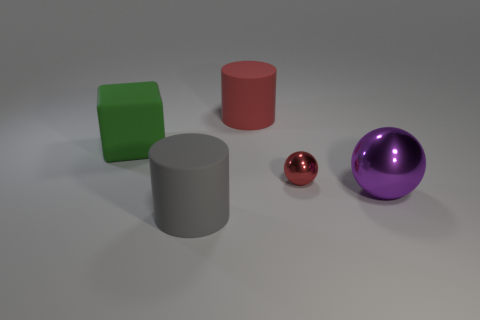Add 1 tiny purple rubber cubes. How many objects exist? 6 Subtract all balls. How many objects are left? 3 Add 3 metallic objects. How many metallic objects are left? 5 Add 5 big yellow balls. How many big yellow balls exist? 5 Subtract 0 blue balls. How many objects are left? 5 Subtract all tiny green things. Subtract all purple shiny spheres. How many objects are left? 4 